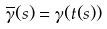<formula> <loc_0><loc_0><loc_500><loc_500>\overline { \gamma } ( s ) = \gamma ( t ( s ) )</formula> 